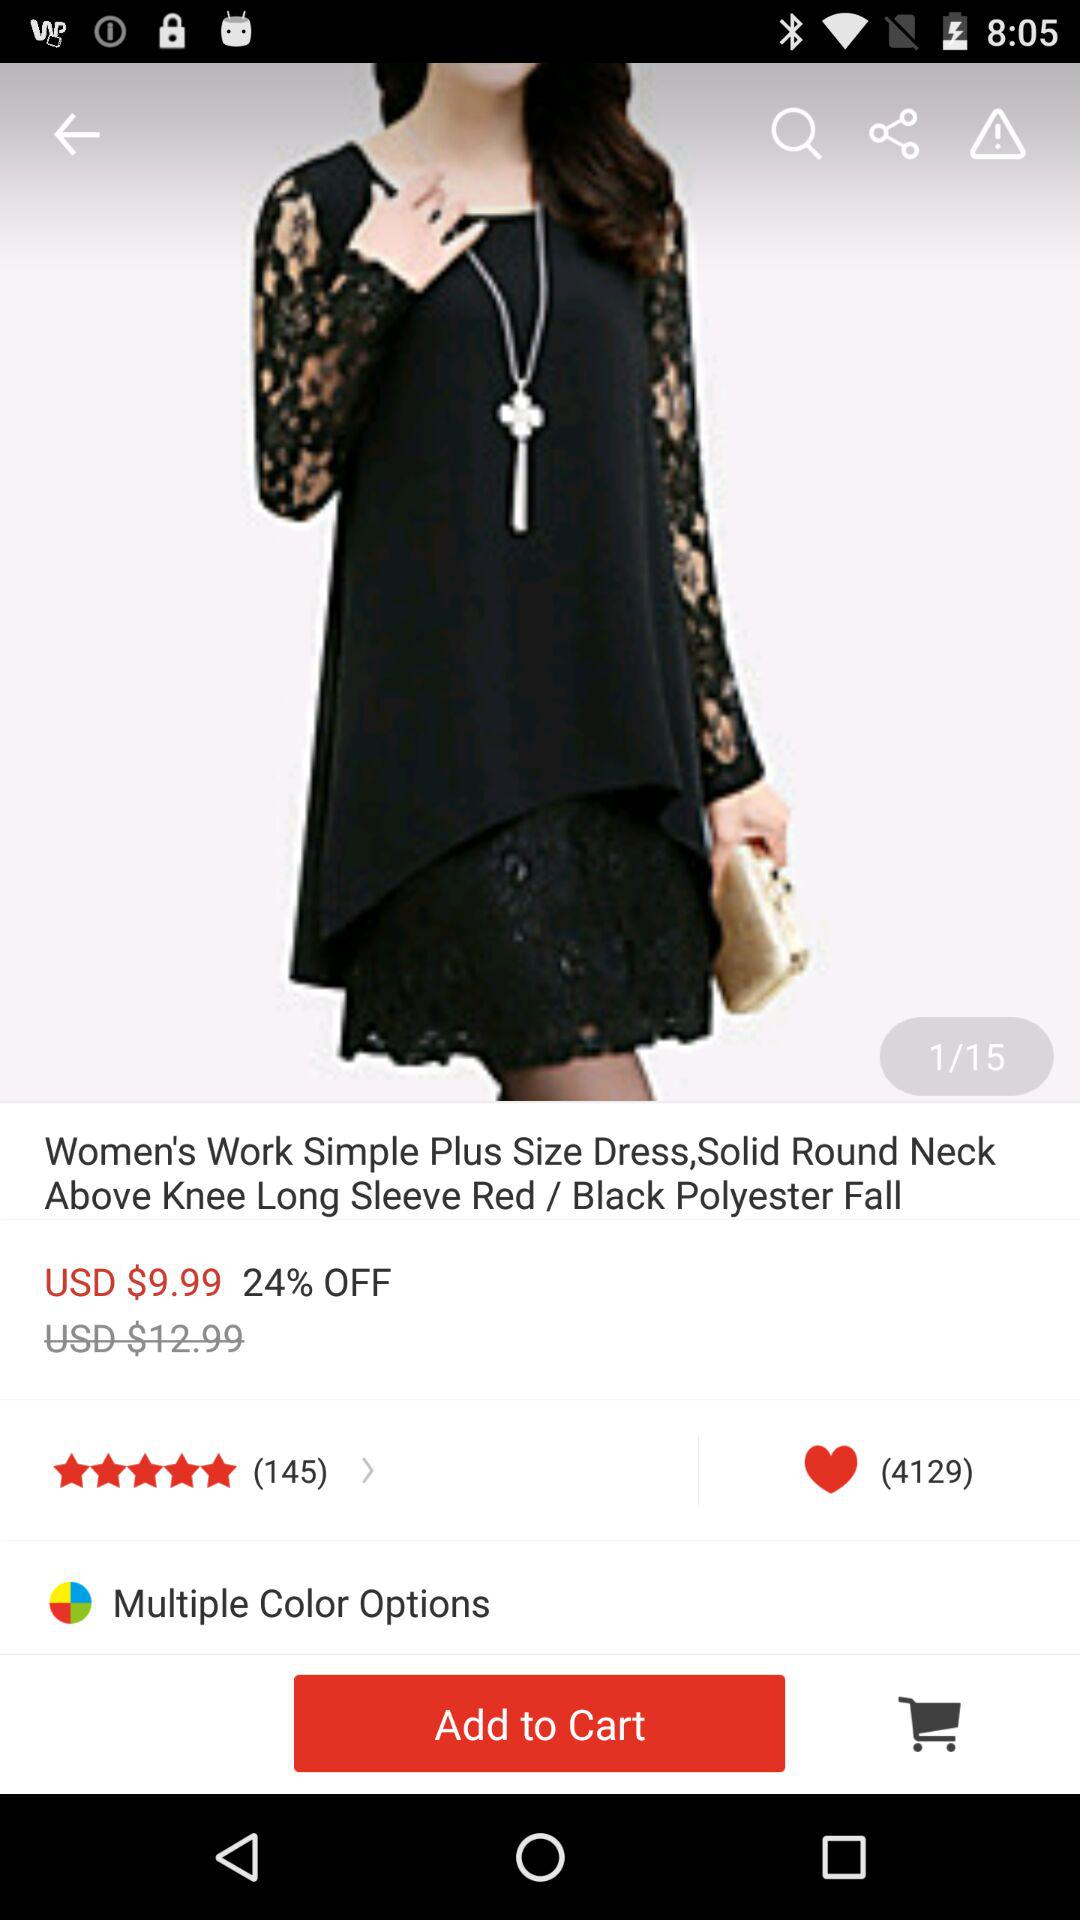How many likes are there of the "Starry Night Sky Projector"? There are 4.5K likes. 